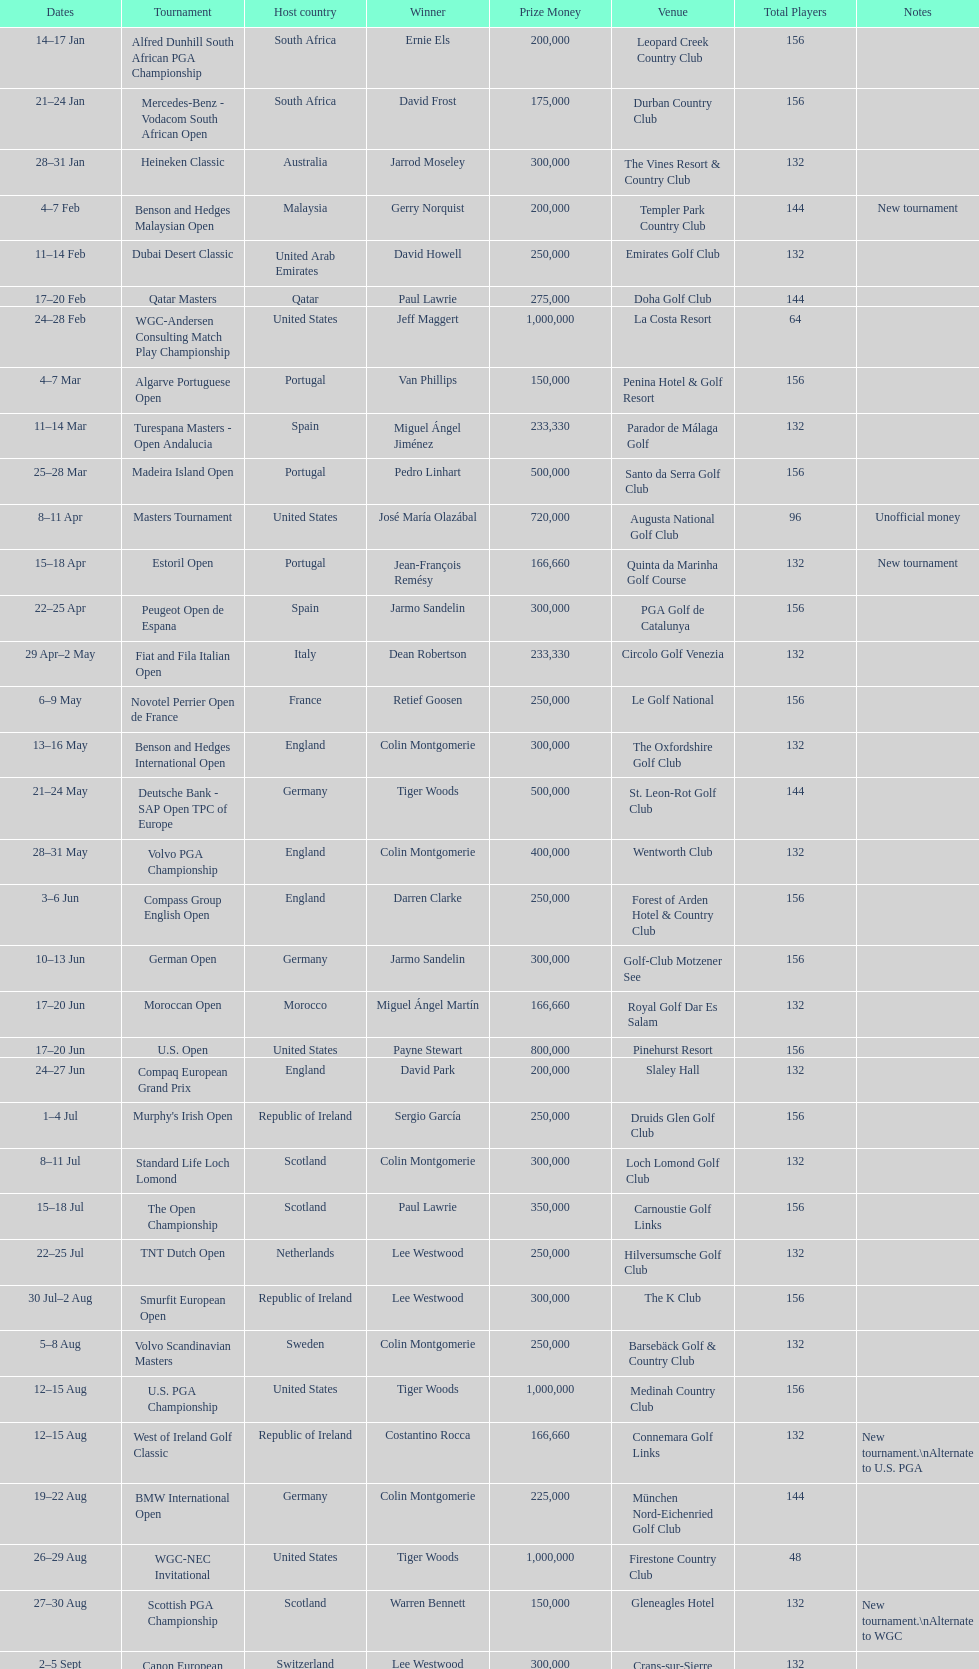Does any country have more than 5 winners? Yes. 